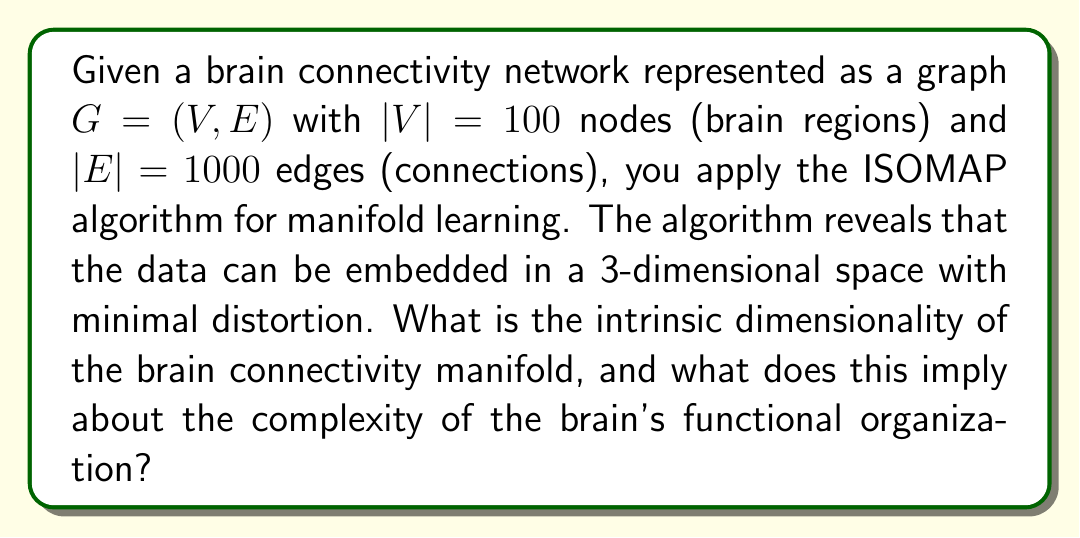Provide a solution to this math problem. To answer this question, we need to understand the concepts of manifold learning and intrinsic dimensionality in the context of brain connectivity networks:

1. Manifold Learning:
   Manifold learning techniques, such as ISOMAP, aim to discover the underlying low-dimensional structure of high-dimensional data. In this case, we're dealing with a brain connectivity network represented as a graph with 100 nodes and 1000 edges.

2. ISOMAP Algorithm:
   ISOMAP (Isometric Feature Mapping) is a nonlinear dimensionality reduction technique that preserves geodesic distances between data points. It works by:
   a) Constructing a neighborhood graph
   b) Computing geodesic distances between all pairs of points
   c) Applying multidimensional scaling (MDS) to the resulting distance matrix

3. Intrinsic Dimensionality:
   The intrinsic dimensionality of a dataset is the minimum number of parameters needed to represent the data without significant information loss. In our case, ISOMAP revealed that the data can be embedded in a 3-dimensional space with minimal distortion.

4. Interpretation:
   The fact that the brain connectivity network can be embedded in a 3-dimensional space suggests that the intrinsic dimensionality of the brain connectivity manifold is 3. This implies that despite the high-dimensional nature of the original data (100 nodes and 1000 edges), the underlying structure of brain connectivity can be described using only 3 dimensions.

5. Implications for Brain Complexity:
   The low intrinsic dimensionality (3) implies that the brain's functional organization, while complex, exhibits a certain level of regularity and structure. This suggests that:
   a) There may be fundamental organizing principles governing brain connectivity
   b) The brain's functional architecture might be more constrained than its structural complexity would suggest
   c) It may be possible to develop simplified models of brain function that capture essential features of connectivity

6. Limitations:
   It's important to note that this result is based on the specific dataset and the ISOMAP algorithm. Different manifold learning techniques or higher-resolution brain connectivity data might yield different results.

In summary, the intrinsic dimensionality of 3 revealed by ISOMAP suggests a relatively low-dimensional structure underlying the brain's functional organization, despite the apparent complexity of the original high-dimensional connectivity data.
Answer: The intrinsic dimensionality of the brain connectivity manifold is 3. This implies that the brain's functional organization, while complex, can be represented in a low-dimensional space, suggesting the existence of fundamental organizing principles and potentially simpler models for understanding brain function. 